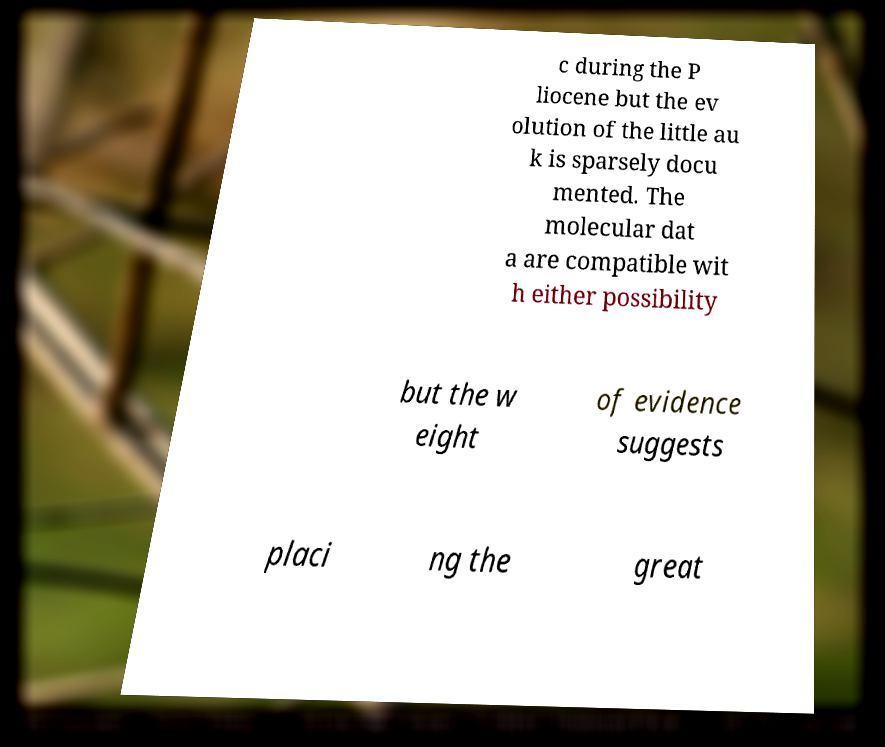Please read and relay the text visible in this image. What does it say? c during the P liocene but the ev olution of the little au k is sparsely docu mented. The molecular dat a are compatible wit h either possibility but the w eight of evidence suggests placi ng the great 